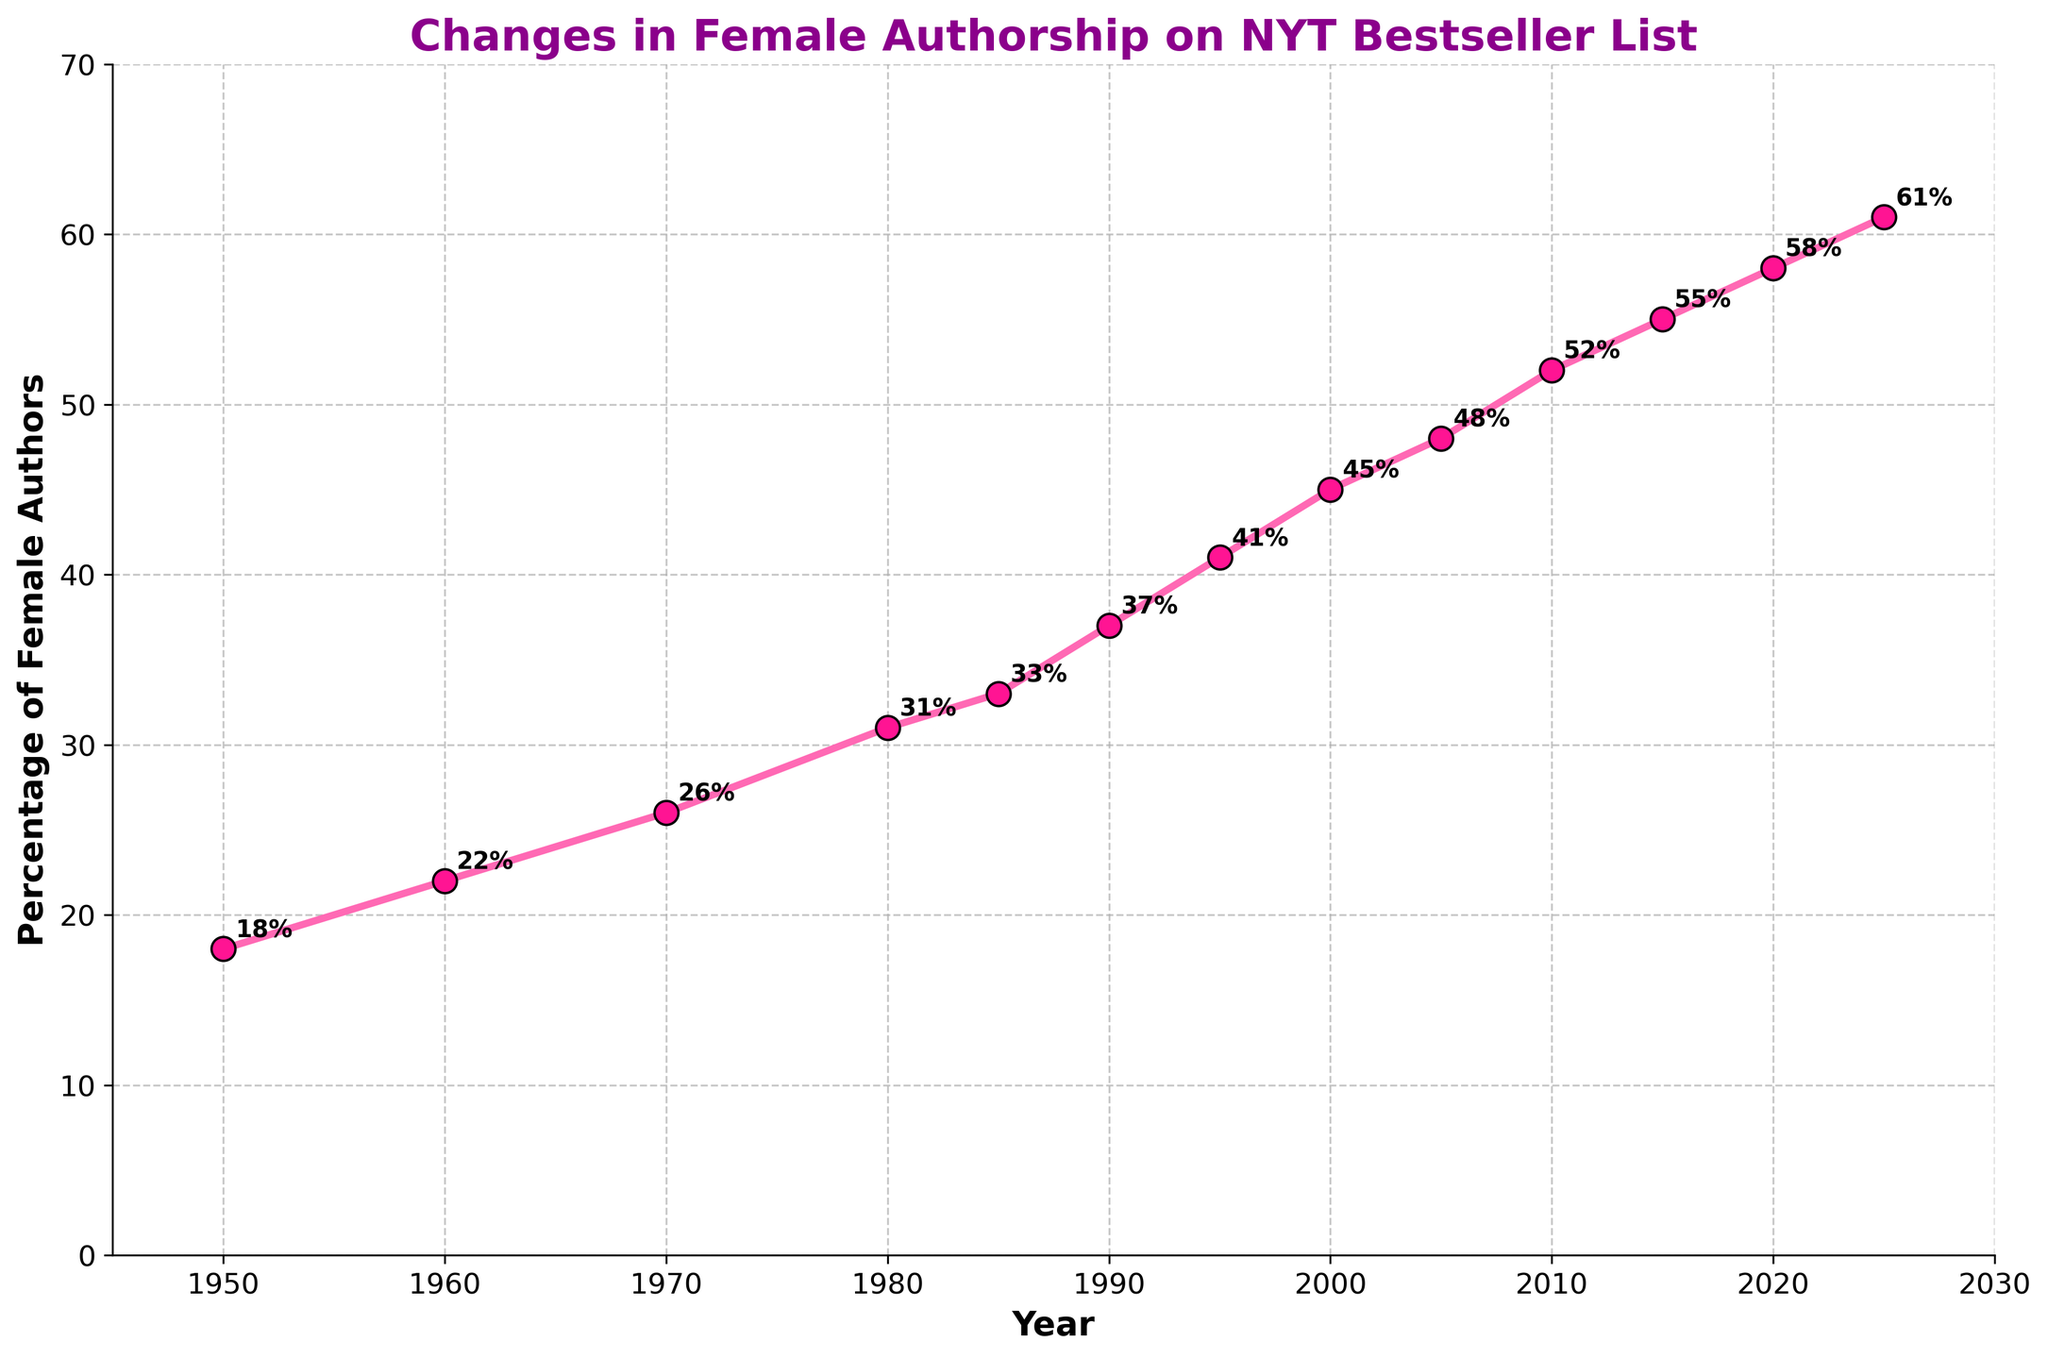What's the percentage of female authors on the NYT Bestseller List in 1985? Look for the data point corresponding to the year 1985. The chart annotation indicates 33%.
Answer: 33% How much did the percentage of female authors increase from 1950 to 2025? Subtract the percentage in 1950 from the percentage in 2025. 61% - 18% = 43%.
Answer: 43% Do the percentage of female authors increase faster after 1990 compared to before 1990? Compare the rate of increase before and after 1990. Before 1990, it went from 18% to 37% in 40 years (an increase of 19%). After 1990, it went from 37% to 61% in 35 years (an increase of 24%).
Answer: Yes What is the median percentage of female authors from 1950 to 2025? List the percentages: 18, 22, 26, 31, 33, 37, 41, 45, 48, 52, 55, 58, 61. Arrange them in ascending order and find the middle value. The median is the 7th value in a list of 13, which is 41%.
Answer: 41% What's the year with the highest percentage of female authors shown on the chart? Identify the highest percentage point visually and find its corresponding year. The chart peaks at 2025 with 61%.
Answer: 2025 Between which two consecutive decades was the percentage change the greatest? Calculate the percentage change for each decade: 1950-1960 (4%), 1960-1970 (4%), 1970-1980 (5%), 1980-1990 (6%), 1990-2000 (4%), 2000-2010 (4%), 2010-2020 (6%), 2020-2025 (3%). The greatest change occurs between 1980 and 1990.
Answer: 1980 and 1990 How much higher is the percentage of female authors in 2025 compared to 2000? Subtract the percentage in 2000 from the percentage in 2025. 61% - 45% = 16%.
Answer: 16% Which decade saw a lower growth rate than the previous decade for female authorship? Calculate changes per decade and compare each to its prior decade: 1950s (4%), 1960s (4%), 1970s (5%), 1980s (6%), 1990s (4%), 2000s (3%), 2010s (6%). The 2000s saw a lower growth rate than the 1990s.
Answer: 2000s Did the percentage of female authors ever decrease in any year shown on the chart? Examine the plot line to see if it ever trends downward. The line consistently trends upwards with no decreases.
Answer: No 